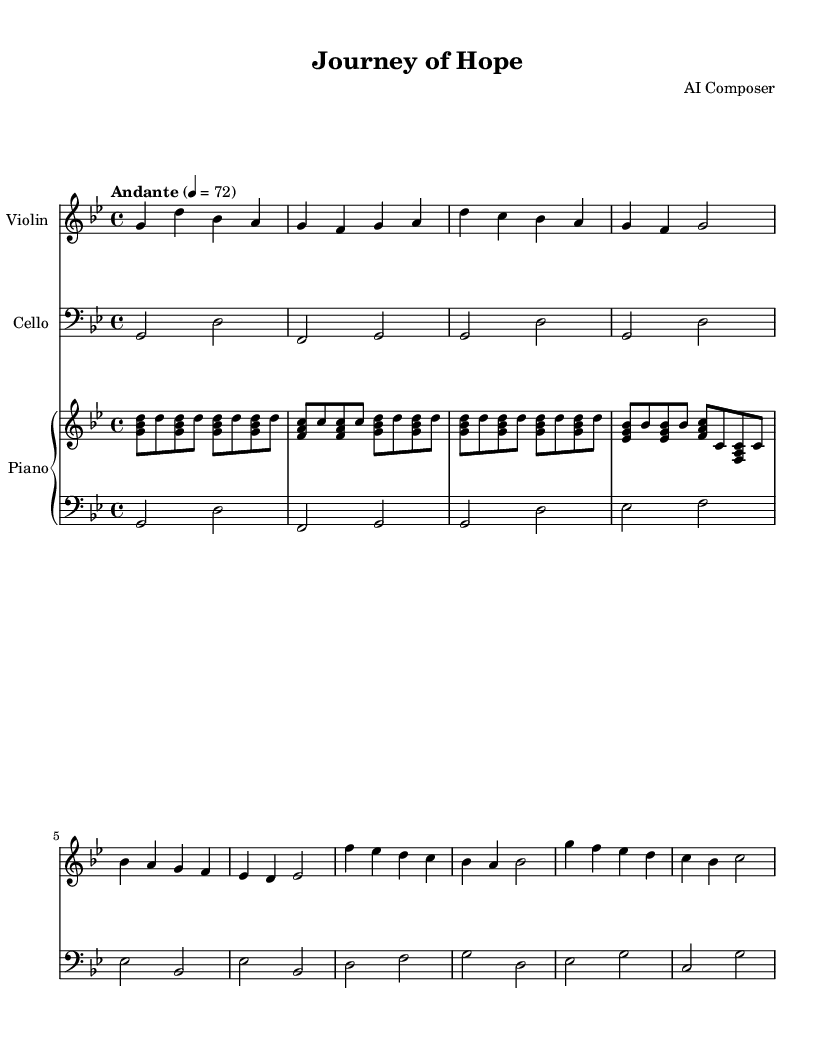What is the key signature of this music? The key signature is indicated at the beginning of the staff, which shows two flats (B♭ and E♭), indicating it is in G minor.
Answer: G minor What is the time signature of this music? The time signature is located at the beginning of the score, demonstrating a 4/4 time signature, which means there are four beats in each measure.
Answer: 4/4 What is the tempo marking for this piece? The tempo marking is indicated above the staff and reads "Andante," which suggests a moderate walking pace, typically around 76-108 beats per minute.
Answer: Andante How many measures are in Theme A? By counting the measures indicated in the violin and cello parts labeled as Theme A, we see there are a total of four measures.
Answer: 4 What is the relationship between the violin and cello in the introduction? The introduction features the violin and cello playing in a call-and-response method, where the cello plays a note followed by the violin playing a corresponding note, creating a dialogue.
Answer: Call-and-response What type of harmony is primarily used in the piano part during Theme B? The piano part during Theme B primarily uses triads and dominant 7th chords, which add to the emotional depth of the music and suggest tension, ideal for film scores that evoke a sense of struggle or longing.
Answer: Triads and dominant 7th chords What emotional quality does the G minor key add to the soundtrack? The G minor key often conveys a sense of sadness or melancholy, which is crucial in soundtracks that depict refugee experiences, enhancing the emotional impact of the scenes.
Answer: Sadness or melancholy 